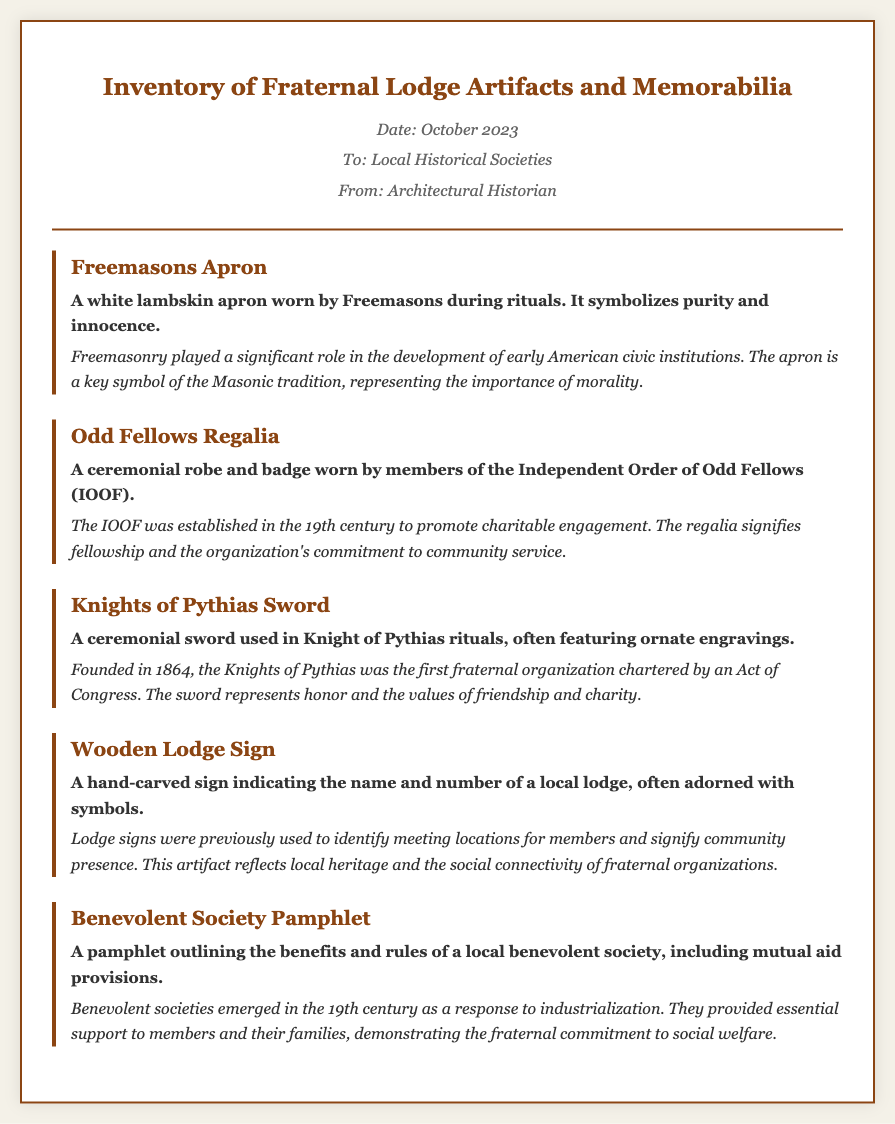What is the date of the memo? The date mentioned in the memo is October 2023.
Answer: October 2023 Who is the memo addressed to? The memo is directed to Local Historical Societies, as stated in the document.
Answer: Local Historical Societies What is represented by the Freemasons apron? The Freemasons apron symbolizes purity and innocence, according to the description.
Answer: Purity and innocence When was the Knights of Pythias founded? The document specifies that the Knights of Pythias was founded in 1864.
Answer: 1864 What does the wooden lodge sign signify? The wooden lodge sign was used to identify meeting locations for members and their community presence.
Answer: Meeting locations and community presence What is the primary purpose of benevolent societies? Benevolent societies provided essential support to members and their families, showcasing a commitment to social welfare.
Answer: Mutual aid What type of item is the Odd Fellows regalia? The Odd Fellows regalia is described as a ceremonial robe and badge worn by members.
Answer: Ceremonial robe and badge What does the sword represent in the Knights of Pythias? The sword represents honor and the values of friendship and charity in the organization.
Answer: Honor and values of friendship and charity 